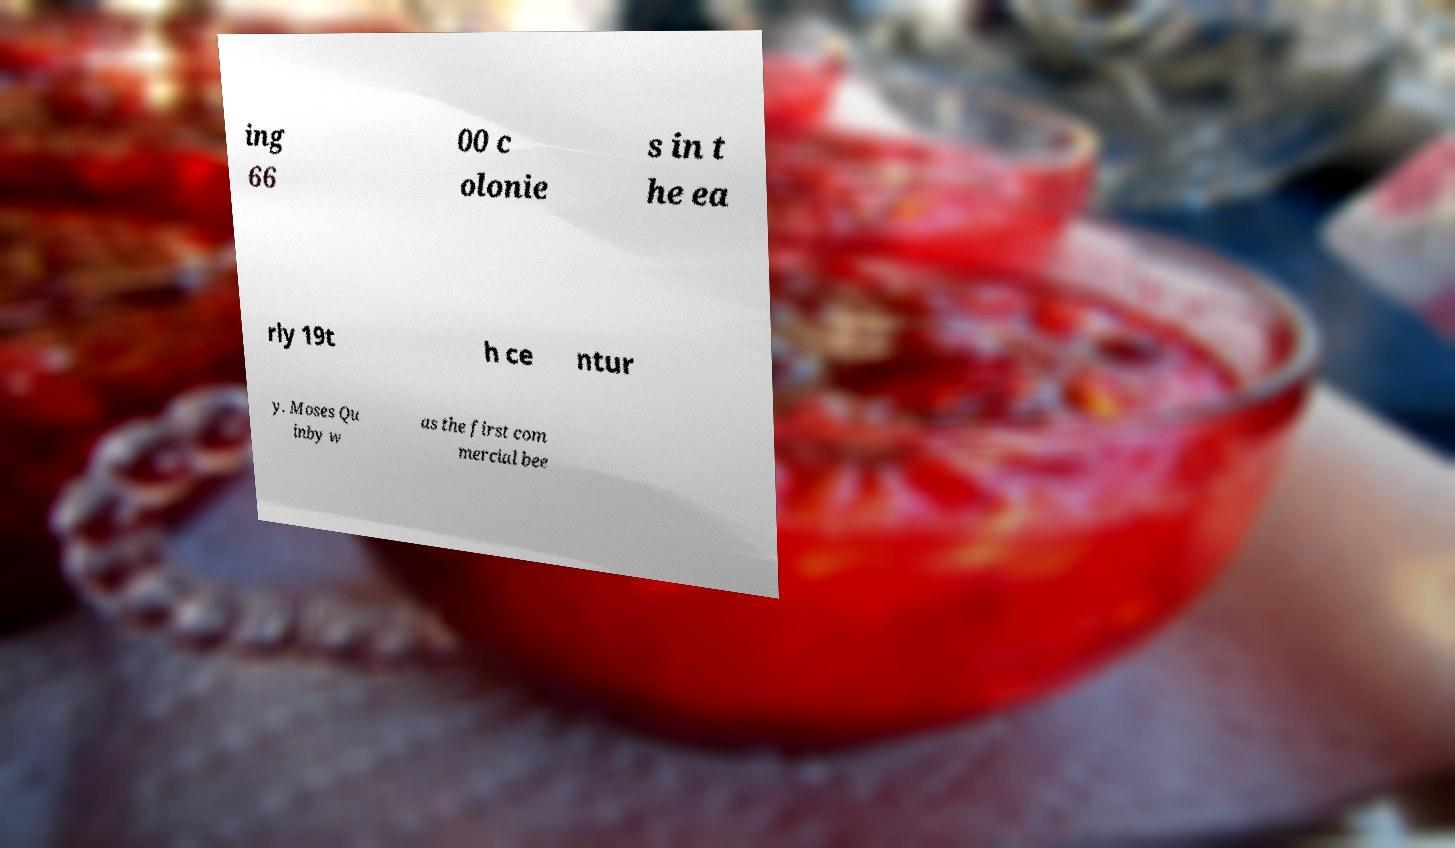Can you accurately transcribe the text from the provided image for me? ing 66 00 c olonie s in t he ea rly 19t h ce ntur y. Moses Qu inby w as the first com mercial bee 